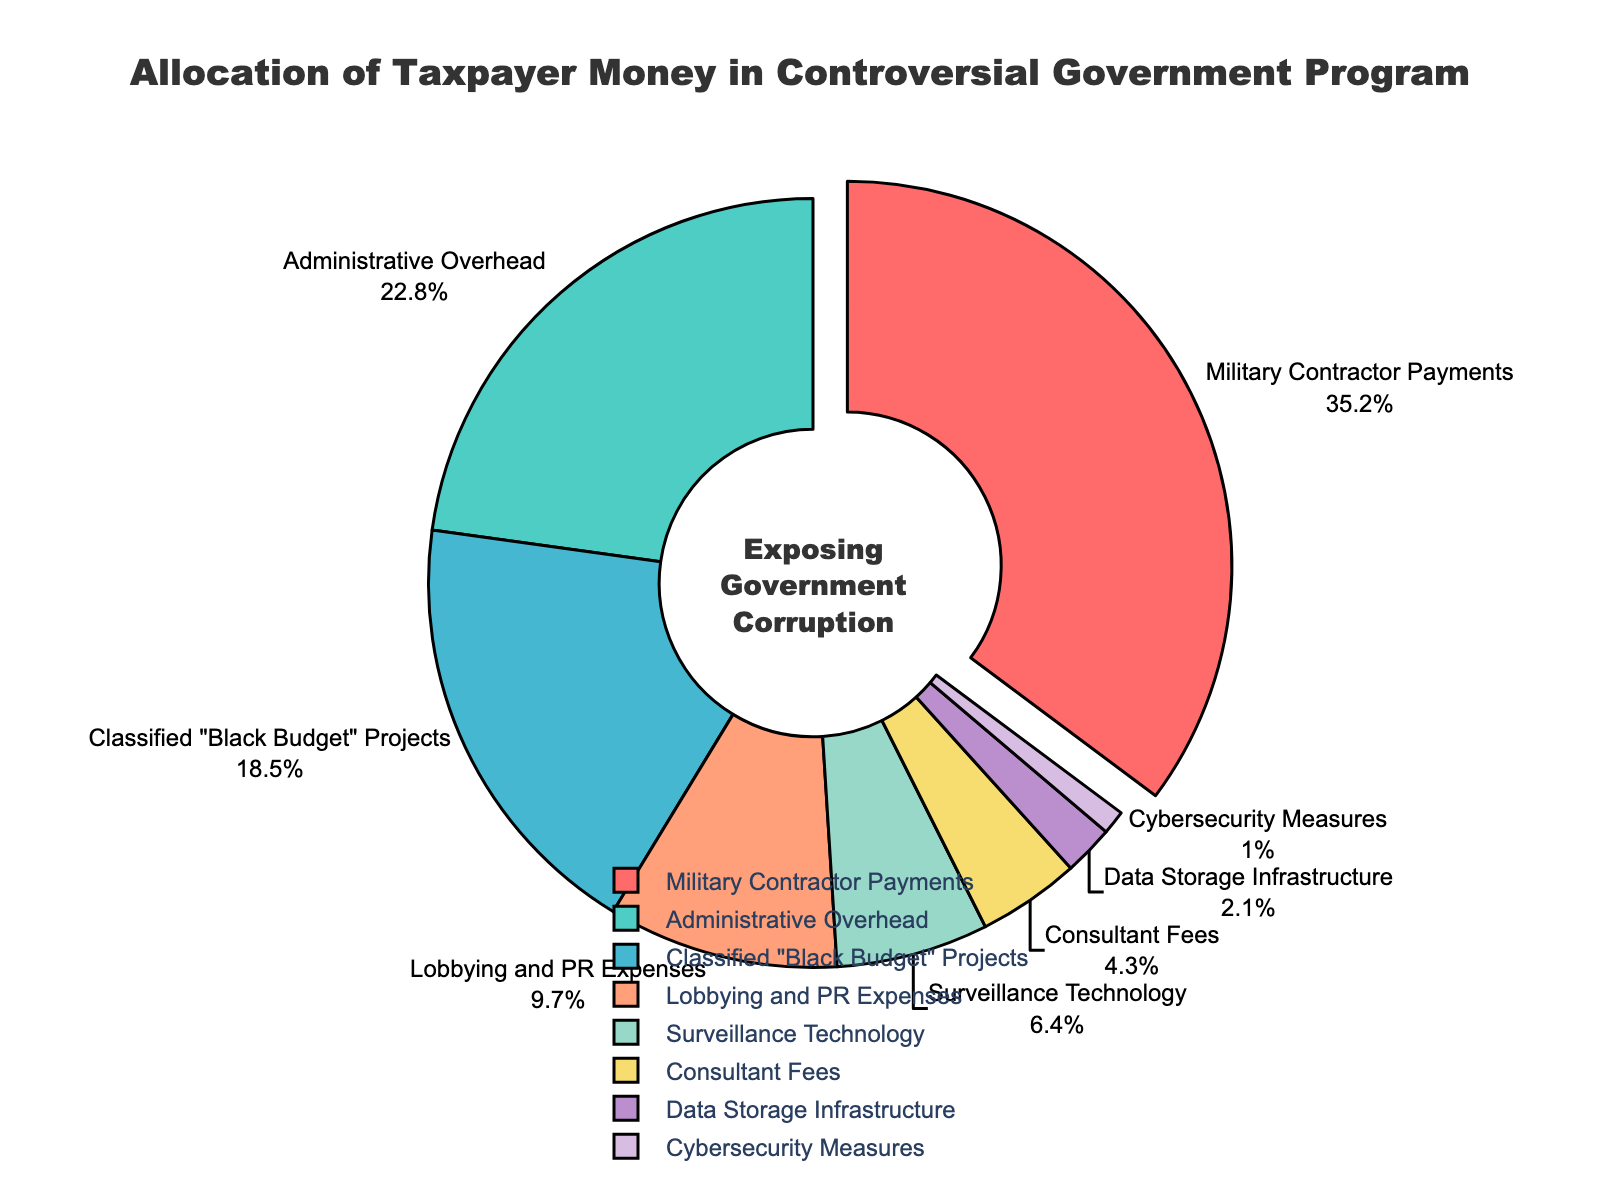What is the largest allocation of taxpayer money in this controversial government program? The largest allocation can be seen from the slice that is slightly pulled out from the pie chart, which is "Military Contractor Payments" at 35.2%.
Answer: Military Contractor Payments How much more percentage is allocated to Administrative Overhead compared to Cybersecurity Measures? Administrative Overhead is 22.8%, and Cybersecurity Measures is 1.0%. The difference is 22.8% - 1.0% = 21.8%.
Answer: 21.8% What is the total percentage allocated to Classified "Black Budget" Projects and Surveillance Technology? Classified "Black Budget" Projects is 18.5%, and Surveillance Technology is 6.4%. The total is 18.5% + 6.4% = 24.9%.
Answer: 24.9% Which program has the smallest allocation percentage and what is it? The smallest slice of the pie chart corresponds to Cybersecurity Measures, which has a percentage allocation of 1.0%.
Answer: Cybersecurity Measures, 1.0% Which two programs together have nearly half of the total allocation percentage? From observing the pie chart, "Military Contractor Payments" (35.2%) and "Administrative Overhead" (22.8%) together account for a large portion. Summing these, 35.2% + 22.8% = 58%, which is over half the total allocation. Hence, we look for the next pairing: "Military Contractor Payments" (35.2%) and "Classified 'Black Budget' Projects" (18.5%) add to 35.2% + 18.5% = 53.7%. This is also over half. Therefore, there are no two programs that together have nearly half of the total. Instead, they surpass it.
Answer: None, they surpass half What is the combined percentage of allocations for Lobbying and PR Expenses and Consultant Fees? Lobbying and PR Expenses is 9.7%, and Consultant Fees is 4.3%. The combined percentage is 9.7% + 4.3% = 14%.
Answer: 14% By how much is the allocation for Surveillance Technology larger or smaller than Data Storage Infrastructure? Surveillance Technology has 6.4% allocation, and Data Storage Infrastructure has 2.1% allocation. The difference is 6.4% - 2.1% = 4.3%.
Answer: 4.3% larger Arrange the first three largest expense categories in the order they are allocated. The first three largest expense categories are "Military Contractor Payments" (35.2%), "Administrative Overhead" (22.8%), and "Classified 'Black Budget' Projects" (18.5%). They are already ordered based on their allocation in descending order.
Answer: Military Contractor Payments, Administrative Overhead, Classified "Black Budget" Projects 